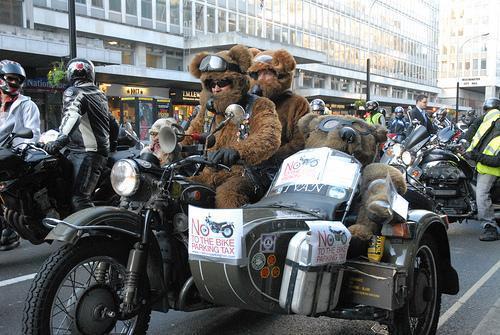How many people are in the photo?
Give a very brief answer. 5. How many motorcycles are visible?
Give a very brief answer. 3. How many red cars are there?
Give a very brief answer. 0. 